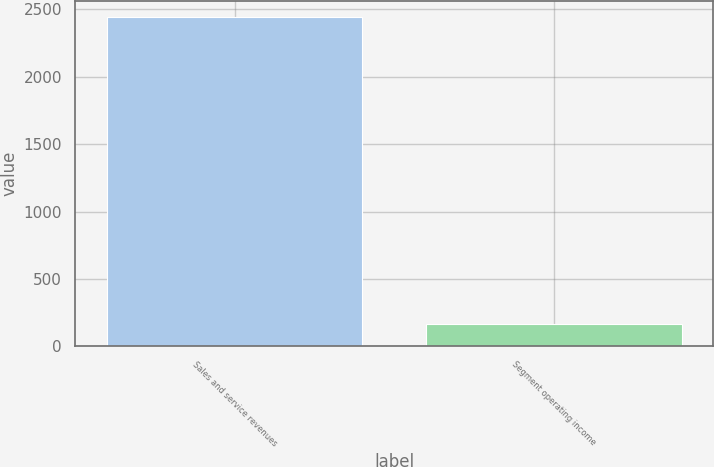Convert chart. <chart><loc_0><loc_0><loc_500><loc_500><bar_chart><fcel>Sales and service revenues<fcel>Segment operating income<nl><fcel>2441<fcel>165<nl></chart> 